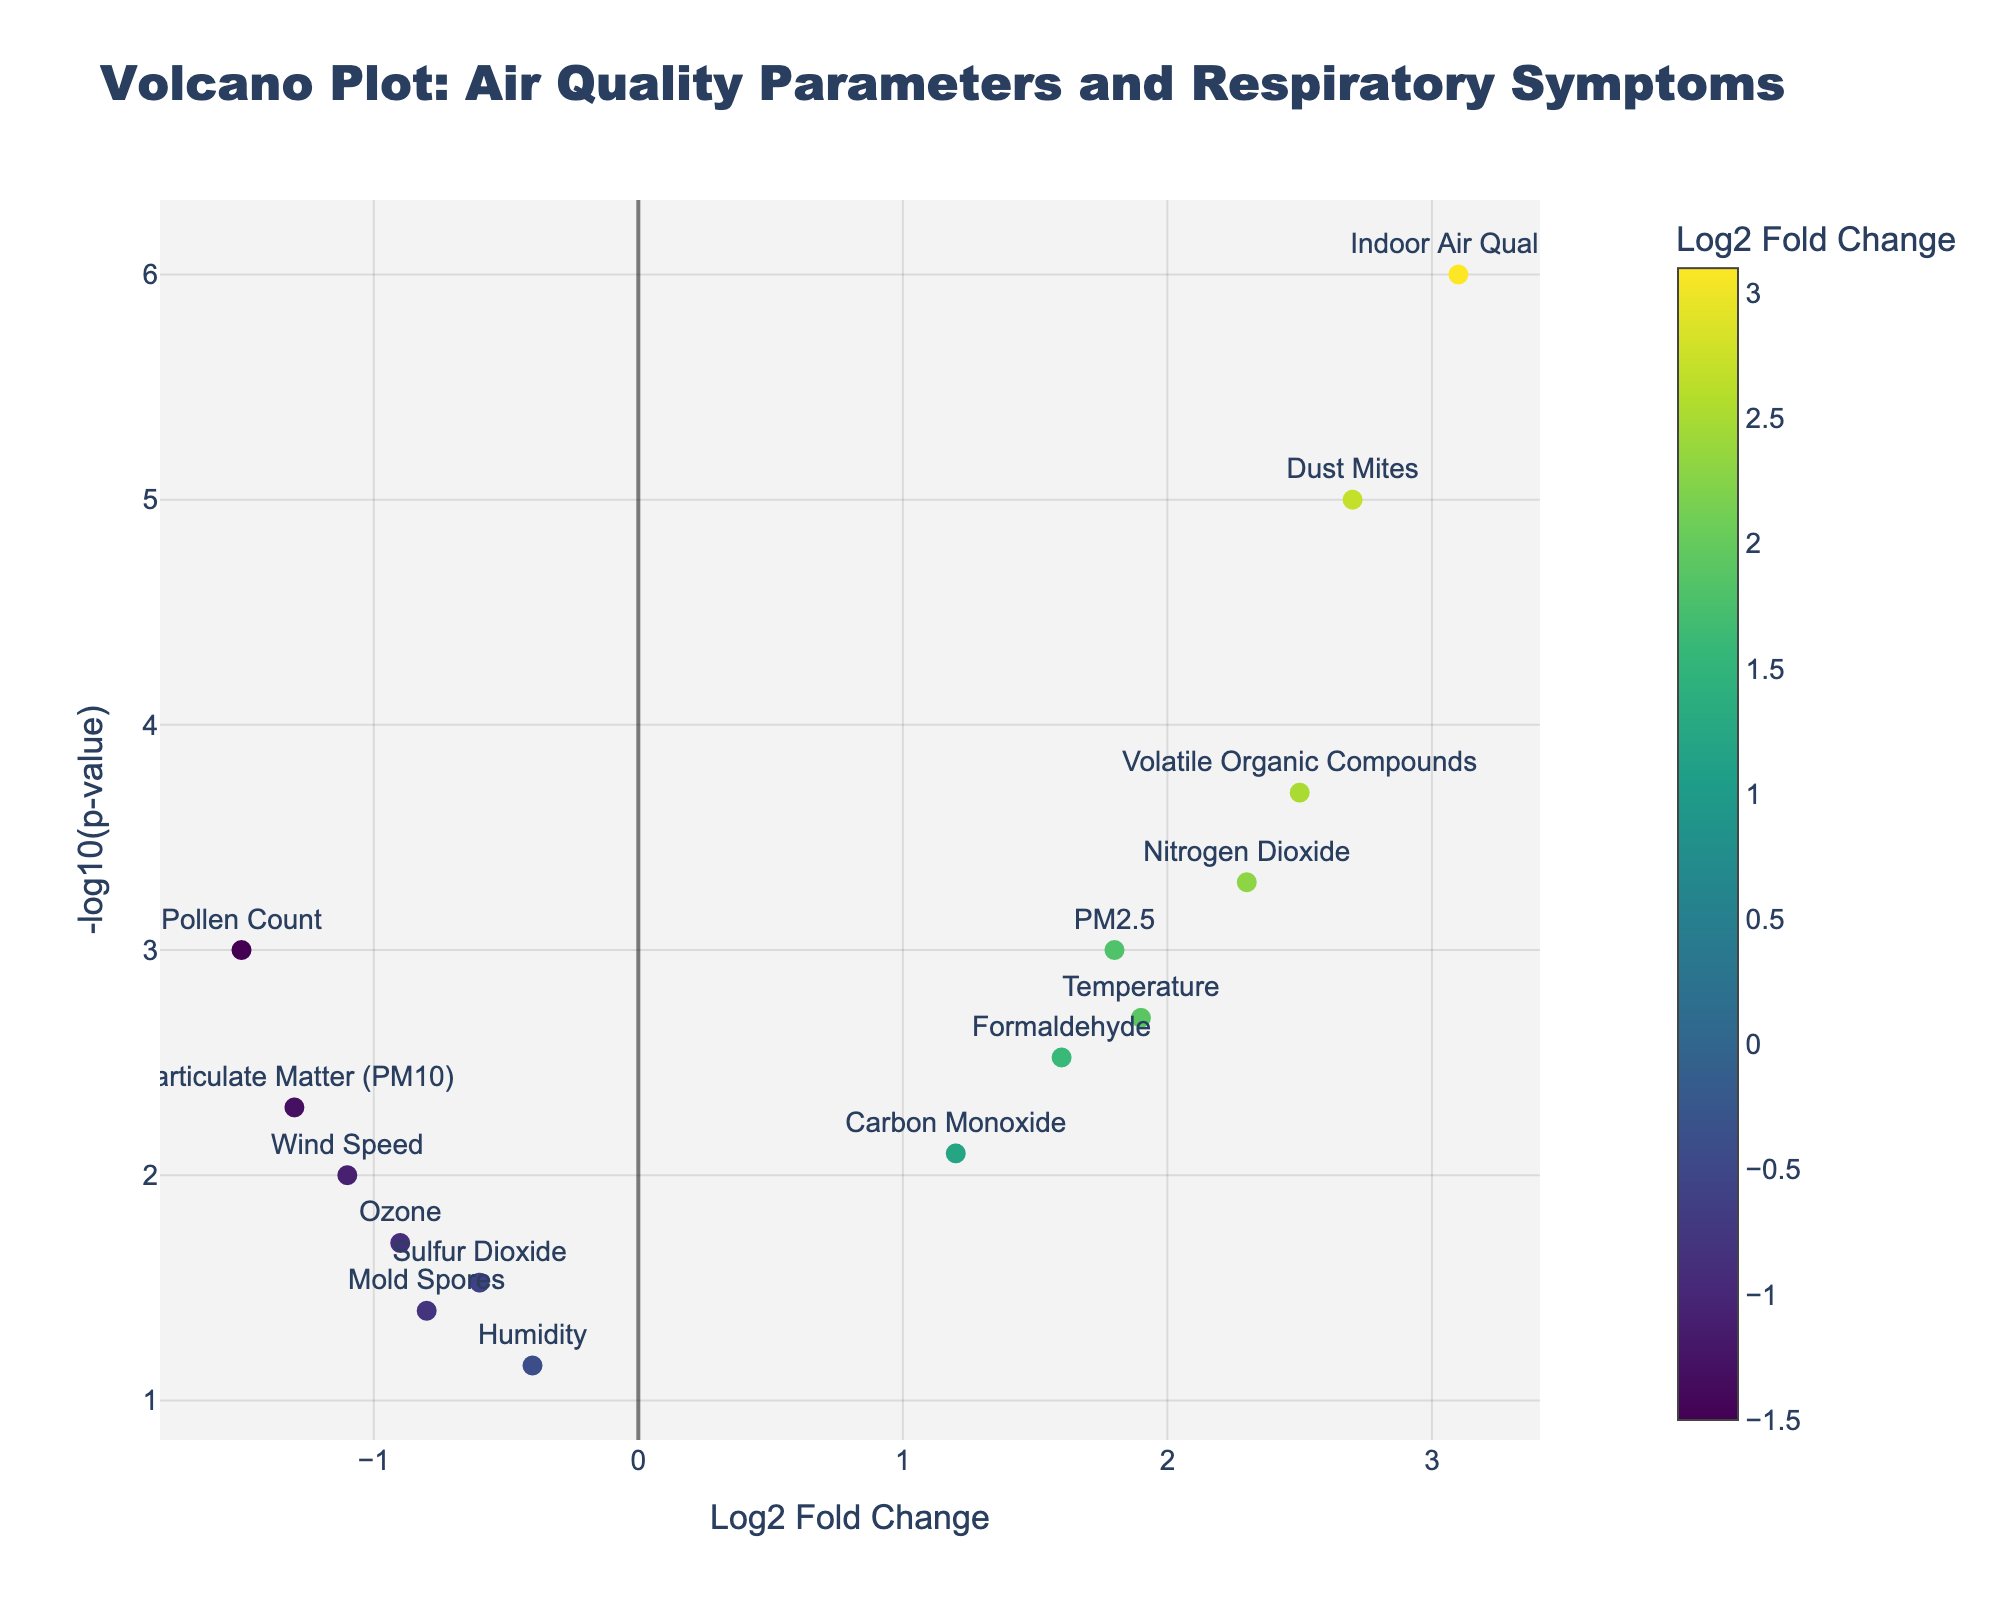How many data points are shown in the plot? By counting the number of markers or points displayed in the plot, we can determine the total number of data points. The data contains 15 different parameters, so there should be 15 data points in the plot.
Answer: 15 What is the significance threshold for the p-values in the plot? A common significance threshold for p-values is 0.05, which corresponds to -log10(0.05) ≈ 1.30 on the y-axis. By observing the plot, we can see where the -log10(p-value) crosses this threshold.
Answer: 0.05 Which parameter has the highest log2 fold change? By examining the x-axis, we can find the parameter furthest to the right. The parameter with the highest log2 fold change is 'Indoor Air Quality' with a log2 fold change of 3.1.
Answer: Indoor Air Quality Which parameter has the lowest p-value? By examining the y-axis (which represents -log10(p-value)), the parameter with the largest value on this axis (highest point) will have the lowest p-value. 'Indoor Air Quality' has the highest -log10(p-value) and thus the lowest p-value.
Answer: Indoor Air Quality What is the log2 fold change of 'Pollen Count'? By locating 'Pollen Count' on the plot and reading its position on the x-axis, we can determine its log2 fold change. 'Pollen Count' has a log2 fold change of -1.5.
Answer: -1.5 What is the parameter with a log2 fold change closest to zero but statistically significant (p < 0.05)? We look for points closest to the origin on the x-axis and check their p-values to see if they meet the significance threshold. 'Sulfur Dioxide' with a log2 fold change of -0.6 and a p-value of 0.03 fits this criterion.
Answer: Sulfur Dioxide Which of the following parameters have a positive log2 fold change and are statistically significant (p < 0.05)? To answer this, we identify parameters with log2 fold changes greater than zero (positive) and check their respective p-values. The parameters 'PM2.5,' 'Nitrogen Dioxide,' 'Carbon Monoxide,' 'Dust Mites,' 'Temperature,' 'Indoor Air Quality,' 'Volatile Organic Compounds,' and 'Formaldehyde' all meet both criteria.
Answer: PM2.5, Nitrogen Dioxide, Carbon Monoxide, Dust Mites, Temperature, Indoor Air Quality, Volatile Organic Compounds, Formaldehyde Which parameter has the second highest -log10(p-value)? By checking the points with the second-highest value on the y-axis, we find that 'Dust Mites' has the second highest -log10(p-value).
Answer: Dust Mites Which has a greater impact on respiratory symptoms in urban areas, 'Nitrogen Dioxide' or 'Volatile Organic Compounds'? To find out, we compare the log2 fold changes of both parameters. 'Volatile Organic Compounds' has a higher log2 fold change (2.5) compared to 'Nitrogen Dioxide' (2.3), indicating it may have a greater impact.
Answer: Volatile Organic Compounds 